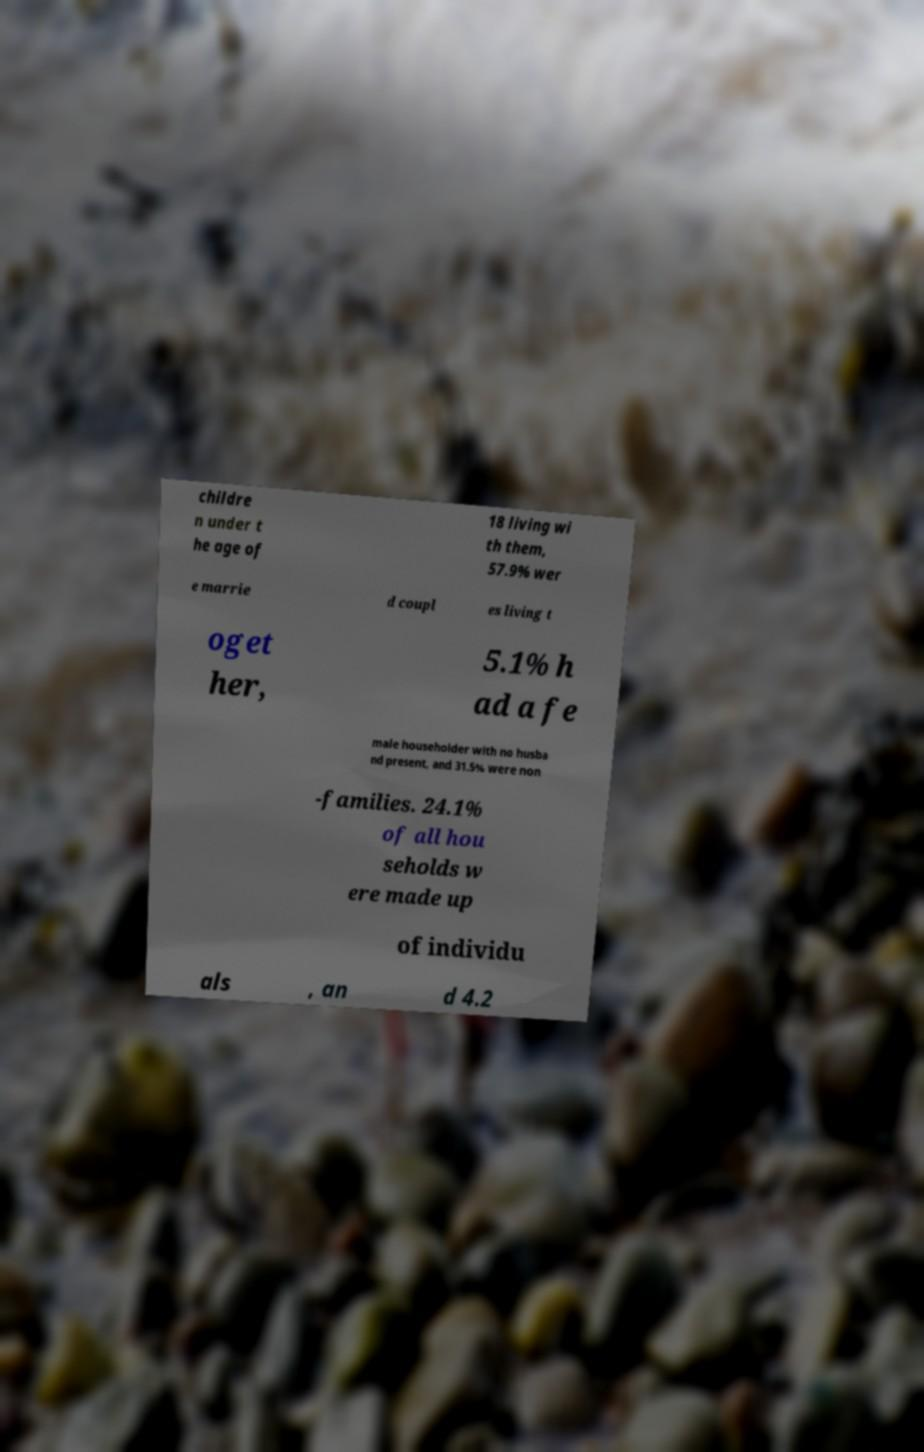Can you read and provide the text displayed in the image?This photo seems to have some interesting text. Can you extract and type it out for me? childre n under t he age of 18 living wi th them, 57.9% wer e marrie d coupl es living t oget her, 5.1% h ad a fe male householder with no husba nd present, and 31.5% were non -families. 24.1% of all hou seholds w ere made up of individu als , an d 4.2 